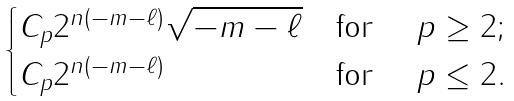<formula> <loc_0><loc_0><loc_500><loc_500>\begin{cases} C _ { p } 2 ^ { n ( - m - \ell ) } \sqrt { - m - \ell } & \text {for } \quad p \geq 2 ; \\ C _ { p } 2 ^ { n ( - m - \ell ) } & \text {for } \quad p \leq 2 . \\ \end{cases}</formula> 